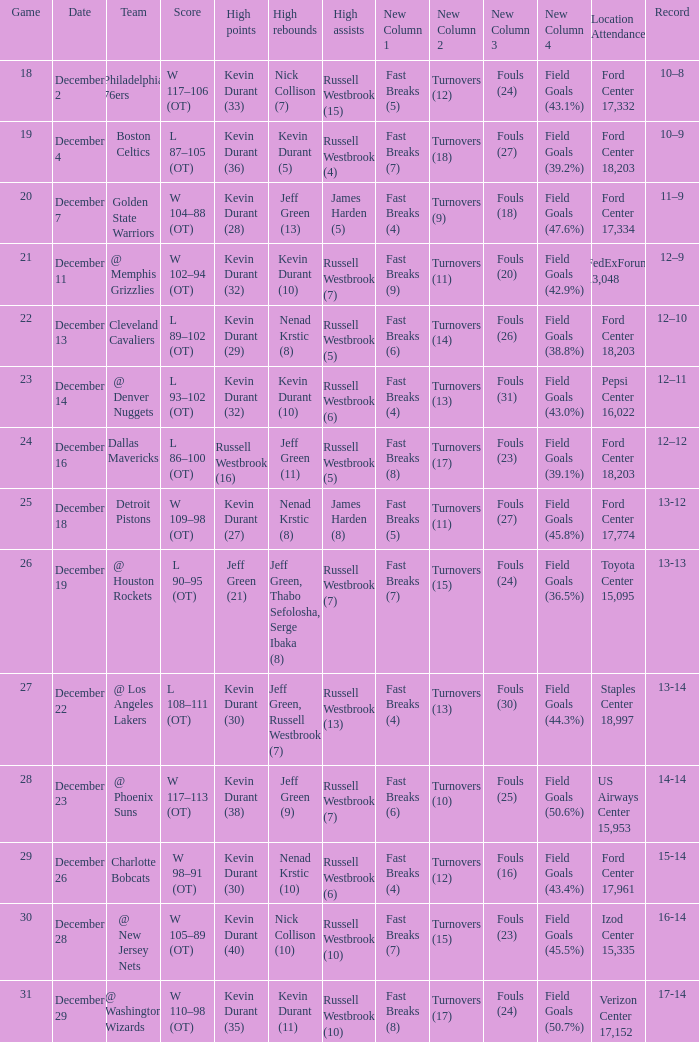What location attendance has russell westbrook (5) as high assists and nenad krstic (8) as high rebounds? Ford Center 18,203. 